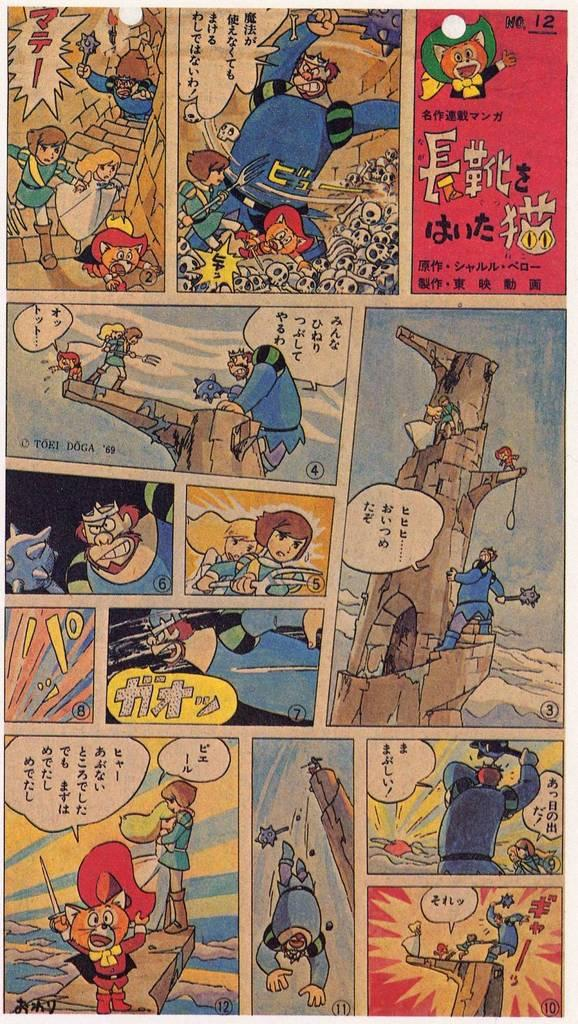What is featured on the poster in the image? The poster contains cartoons. What is the context of the poster? The poster is related to a college. Is there any text on the poster? Yes, there is text written on the poster. How many people are standing on the hill in the image? There is no hill or crowd of people present in the image; it only features a poster related to a college. What type of pest can be seen crawling on the poster in the image? There are no pests visible on the poster in the image. 